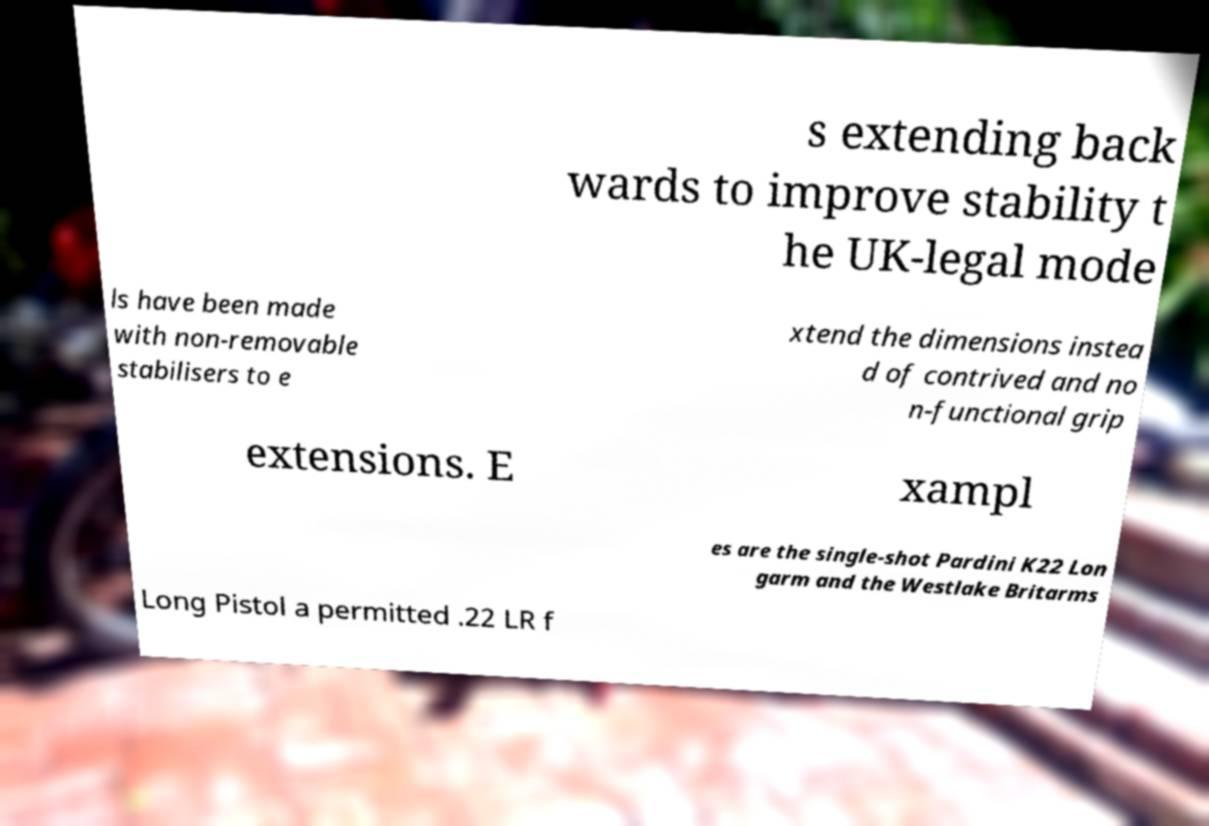Could you assist in decoding the text presented in this image and type it out clearly? s extending back wards to improve stability t he UK-legal mode ls have been made with non-removable stabilisers to e xtend the dimensions instea d of contrived and no n-functional grip extensions. E xampl es are the single-shot Pardini K22 Lon garm and the Westlake Britarms Long Pistol a permitted .22 LR f 